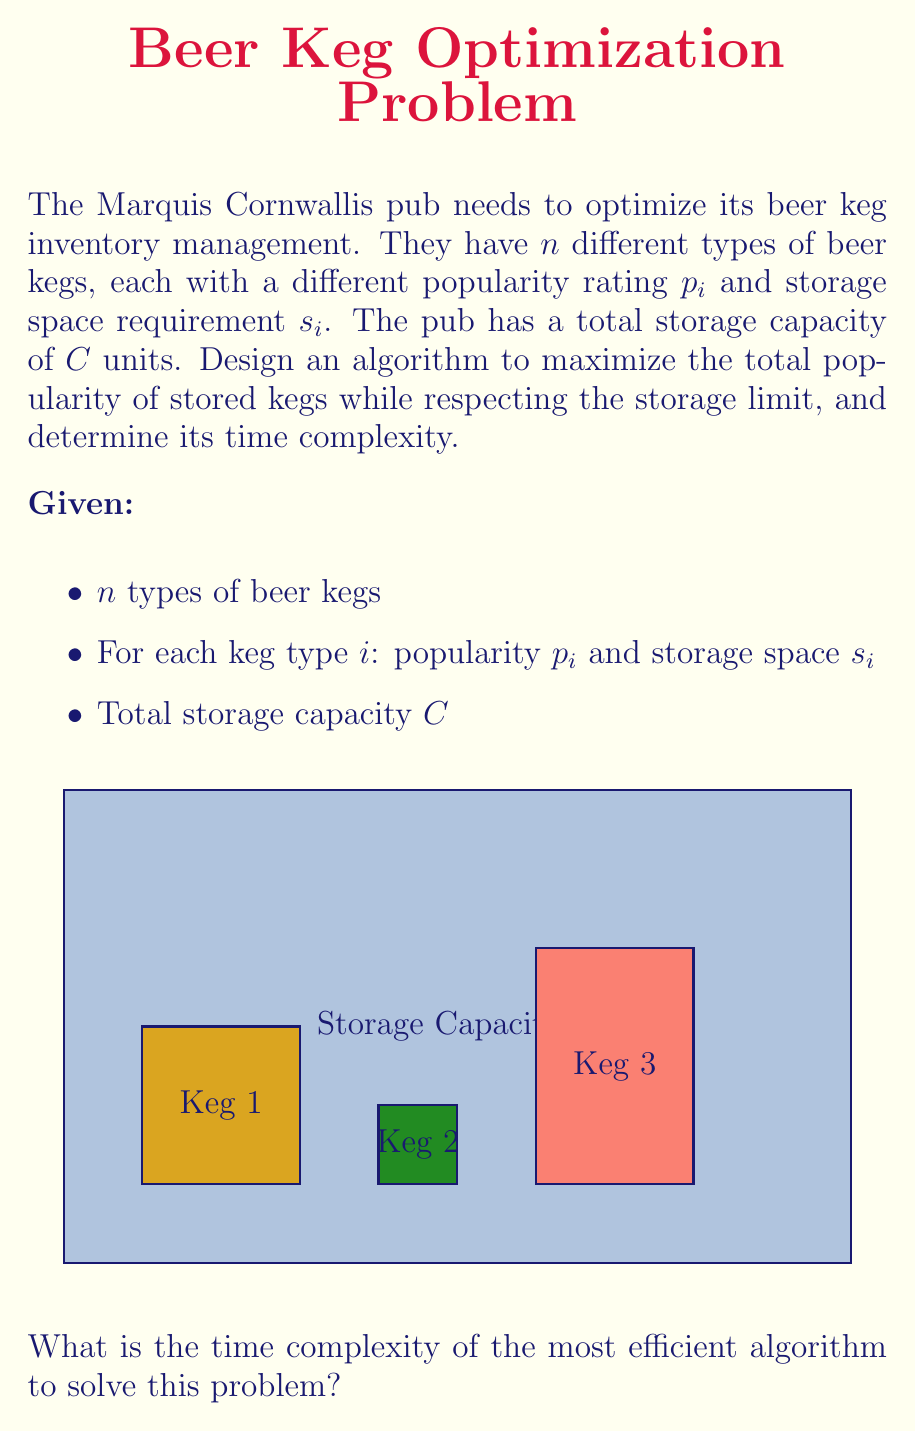Could you help me with this problem? To solve this problem, we can recognize it as a variation of the 0/1 Knapsack problem, where we want to maximize the total value (popularity) of items (kegs) we can put in a knapsack (storage) with a weight limit (capacity).

The most efficient known algorithm for solving the 0/1 Knapsack problem is Dynamic Programming. Here's how we can approach this:

1) Create a 2D array $dp[i][w]$ where $i$ represents the first $i$ types of kegs and $w$ represents the current storage capacity (from 0 to $C$).

2) The recurrence relation for filling this array is:

   $$dp[i][w] = \max(dp[i-1][w], dp[i-1][w-s_i] + p_i)$$

   This means for each keg type and each possible storage capacity, we choose the maximum of:
   a) Not including this keg type (using the solution for the previous $i-1$ types)
   b) Including this keg type (adding its popularity to the solution for the previous $i-1$ types with $s_i$ less capacity)

3) We fill this array iteratively, starting from $dp[0][w] = 0$ for all $w$, and $dp[i][0] = 0$ for all $i$.

4) The final answer will be in $dp[n][C]$.

The time complexity of this algorithm is $O(nC)$, where $n$ is the number of keg types and $C$ is the total storage capacity. This is because we need to fill an $n \times C$ array, and each cell takes constant time to compute.

While this is pseudo-polynomial time (polynomial in the numeric value of the input), it's considered the most efficient known algorithm for this problem, as the Knapsack problem is NP-complete and no polynomial-time algorithm is known.

Space complexity is also $O(nC)$ for the full DP table, but can be optimized to $O(C)$ by only keeping the last two rows at any time.
Answer: $O(nC)$ 